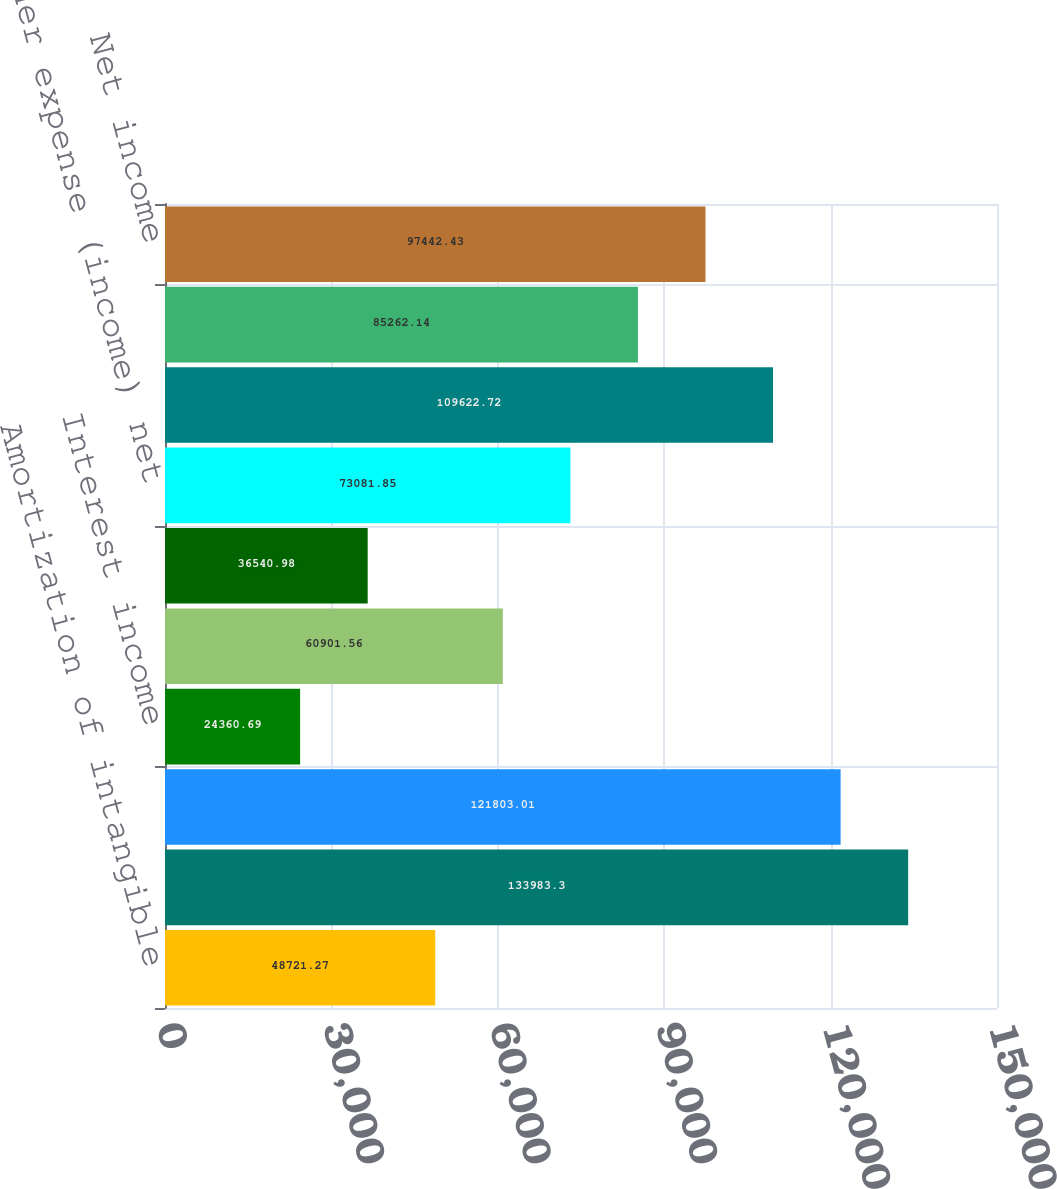<chart> <loc_0><loc_0><loc_500><loc_500><bar_chart><fcel>Amortization of intangible<fcel>Total operating expenses<fcel>Operating income<fcel>Interest income<fcel>Interest expense<fcel>Other expense<fcel>Other expense (income) net<fcel>Income before provision for<fcel>Provision for income taxes<fcel>Net income<nl><fcel>48721.3<fcel>133983<fcel>121803<fcel>24360.7<fcel>60901.6<fcel>36541<fcel>73081.9<fcel>109623<fcel>85262.1<fcel>97442.4<nl></chart> 